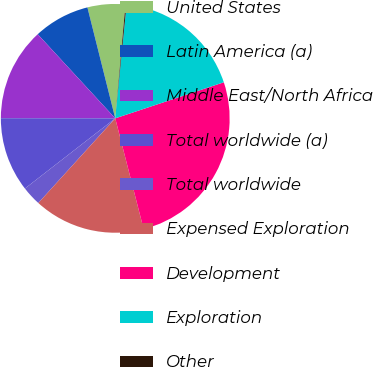Convert chart to OTSL. <chart><loc_0><loc_0><loc_500><loc_500><pie_chart><fcel>United States<fcel>Latin America (a)<fcel>Middle East/North Africa<fcel>Total worldwide (a)<fcel>Total worldwide<fcel>Expensed Exploration<fcel>Development<fcel>Exploration<fcel>Other<nl><fcel>5.34%<fcel>7.94%<fcel>13.13%<fcel>10.53%<fcel>2.75%<fcel>15.73%<fcel>26.11%<fcel>18.32%<fcel>0.15%<nl></chart> 